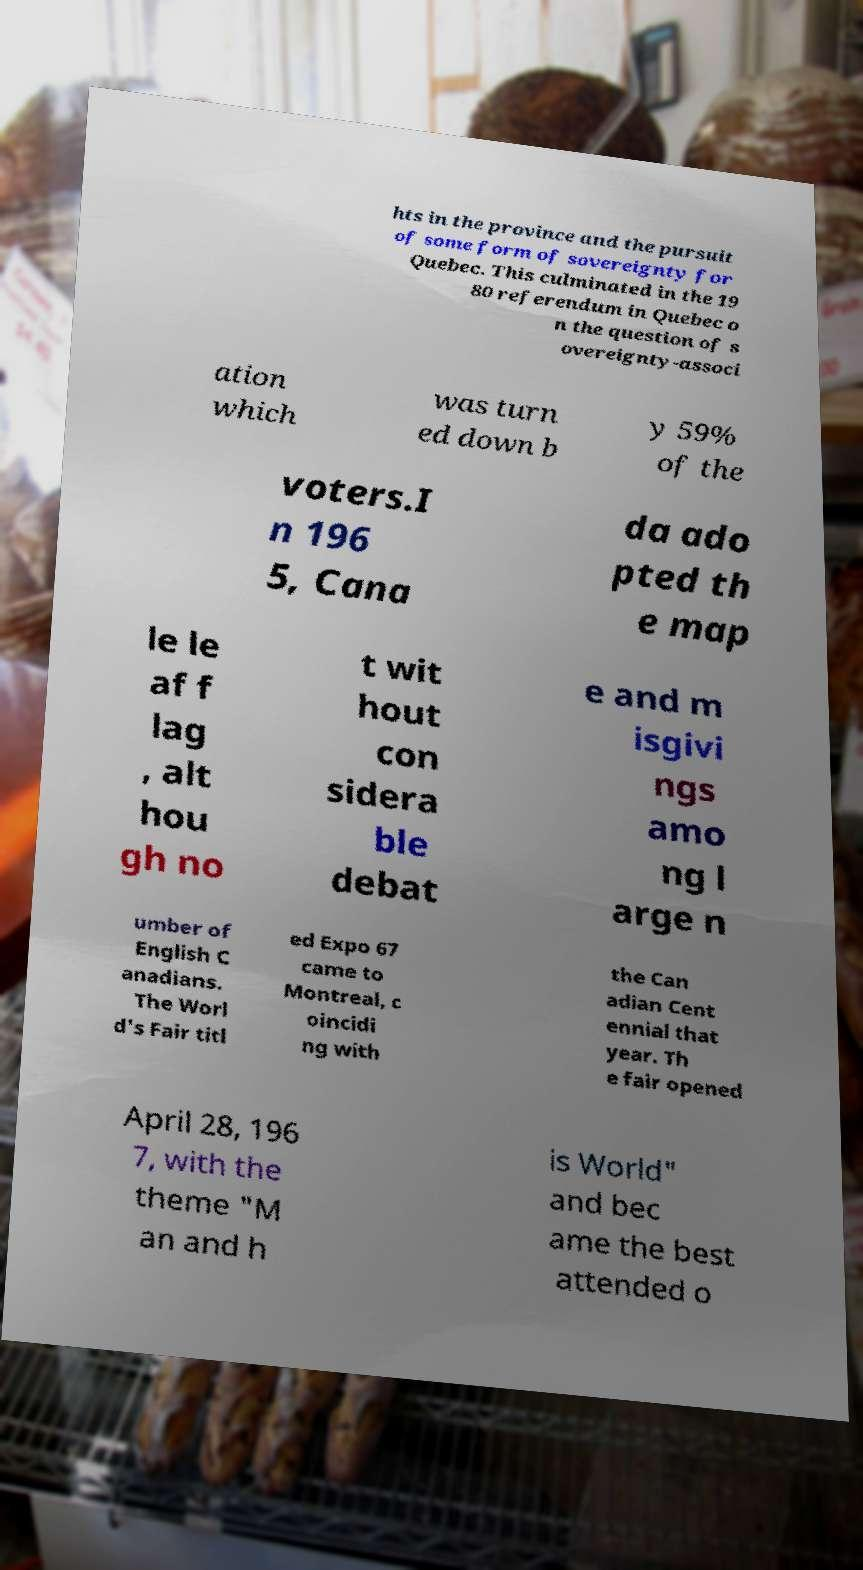Could you extract and type out the text from this image? hts in the province and the pursuit of some form of sovereignty for Quebec. This culminated in the 19 80 referendum in Quebec o n the question of s overeignty-associ ation which was turn ed down b y 59% of the voters.I n 196 5, Cana da ado pted th e map le le af f lag , alt hou gh no t wit hout con sidera ble debat e and m isgivi ngs amo ng l arge n umber of English C anadians. The Worl d's Fair titl ed Expo 67 came to Montreal, c oincidi ng with the Can adian Cent ennial that year. Th e fair opened April 28, 196 7, with the theme "M an and h is World" and bec ame the best attended o 